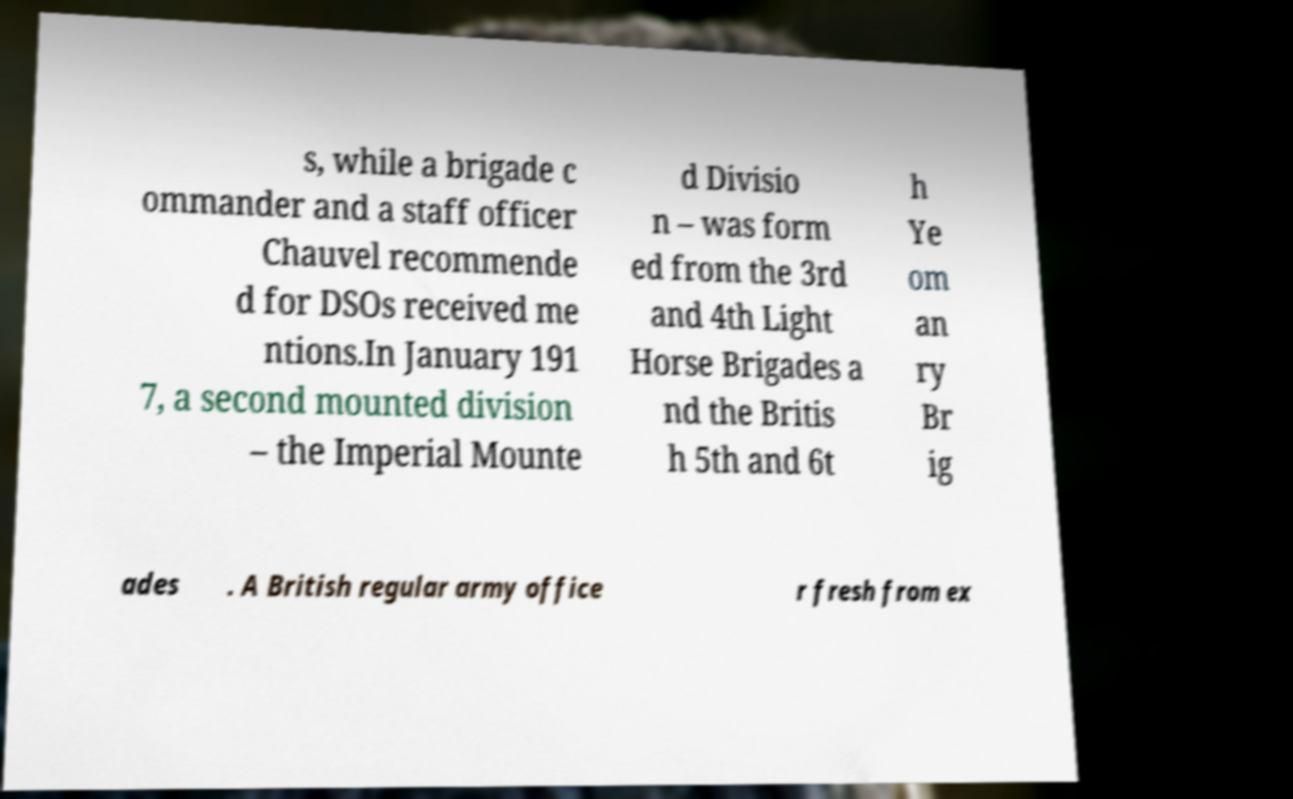Could you assist in decoding the text presented in this image and type it out clearly? s, while a brigade c ommander and a staff officer Chauvel recommende d for DSOs received me ntions.In January 191 7, a second mounted division – the Imperial Mounte d Divisio n – was form ed from the 3rd and 4th Light Horse Brigades a nd the Britis h 5th and 6t h Ye om an ry Br ig ades . A British regular army office r fresh from ex 